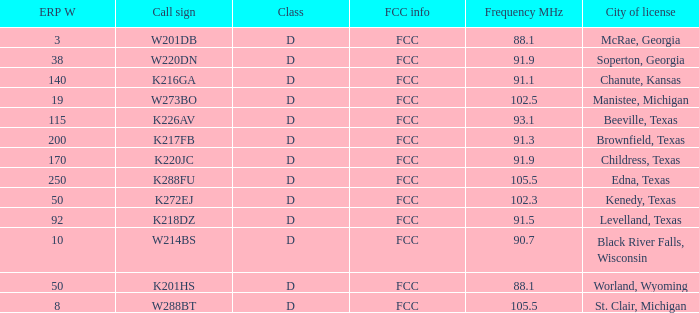What is Call Sign, when ERP W is greater than 50? K216GA, K226AV, K217FB, K220JC, K288FU, K218DZ. Could you parse the entire table as a dict? {'header': ['ERP W', 'Call sign', 'Class', 'FCC info', 'Frequency MHz', 'City of license'], 'rows': [['3', 'W201DB', 'D', 'FCC', '88.1', 'McRae, Georgia'], ['38', 'W220DN', 'D', 'FCC', '91.9', 'Soperton, Georgia'], ['140', 'K216GA', 'D', 'FCC', '91.1', 'Chanute, Kansas'], ['19', 'W273BO', 'D', 'FCC', '102.5', 'Manistee, Michigan'], ['115', 'K226AV', 'D', 'FCC', '93.1', 'Beeville, Texas'], ['200', 'K217FB', 'D', 'FCC', '91.3', 'Brownfield, Texas'], ['170', 'K220JC', 'D', 'FCC', '91.9', 'Childress, Texas'], ['250', 'K288FU', 'D', 'FCC', '105.5', 'Edna, Texas'], ['50', 'K272EJ', 'D', 'FCC', '102.3', 'Kenedy, Texas'], ['92', 'K218DZ', 'D', 'FCC', '91.5', 'Levelland, Texas'], ['10', 'W214BS', 'D', 'FCC', '90.7', 'Black River Falls, Wisconsin'], ['50', 'K201HS', 'D', 'FCC', '88.1', 'Worland, Wyoming'], ['8', 'W288BT', 'D', 'FCC', '105.5', 'St. Clair, Michigan']]} 